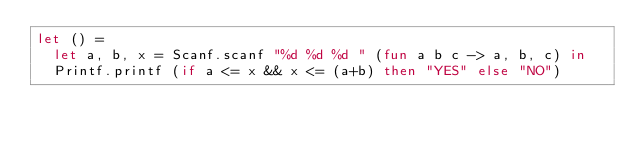Convert code to text. <code><loc_0><loc_0><loc_500><loc_500><_OCaml_>let () =
  let a, b, x = Scanf.scanf "%d %d %d " (fun a b c -> a, b, c) in
  Printf.printf (if a <= x && x <= (a+b) then "YES" else "NO")</code> 